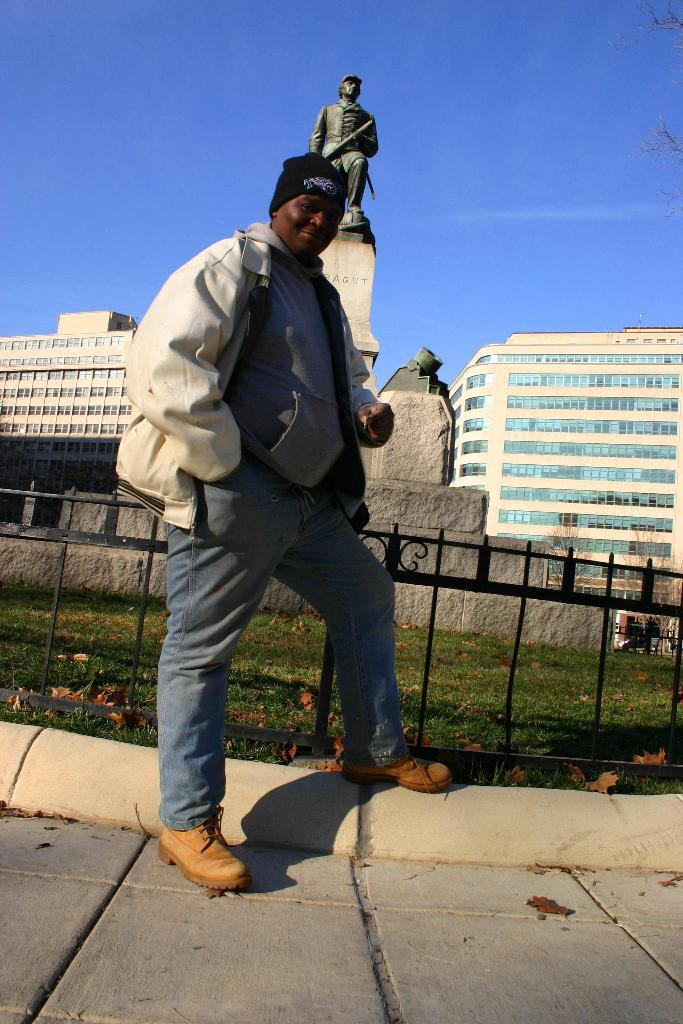Who or what is present in the image? There is a person in the image. What is the person wearing? The person is wearing a jacket and cap. What can be seen near the person? There is a railing in the image. What type of natural environment is visible in the image? There is grass in the image. What other objects or structures can be seen in the image? There is a statue and stone in the image. What is visible in the background of the image? There are buildings and the sky in the background of the image. What type of hook is being used to hold the yarn in the image? There is no hook or yarn present in the image. How does the sleet affect the person's clothing in the image? There is no sleet present in the image, so it does not affect the person's clothing. 